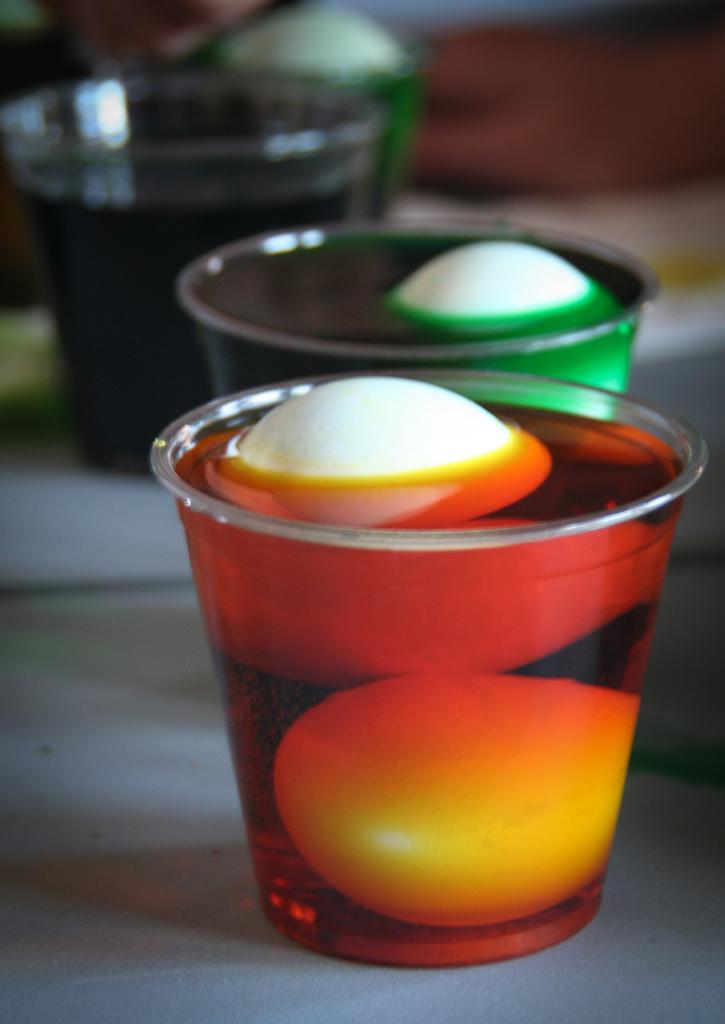What objects can be seen in the image? There are glasses in the image. What is inside the glasses? There is a drink present in the glasses. Can you describe the background of the image? The background of the image is blurry. What type of jelly is being served in the glasses? There is no jelly present in the image; the glasses contain a drink. What class is being taught in the background of the image? There is no class or educational setting present in the image; the background is blurry. 